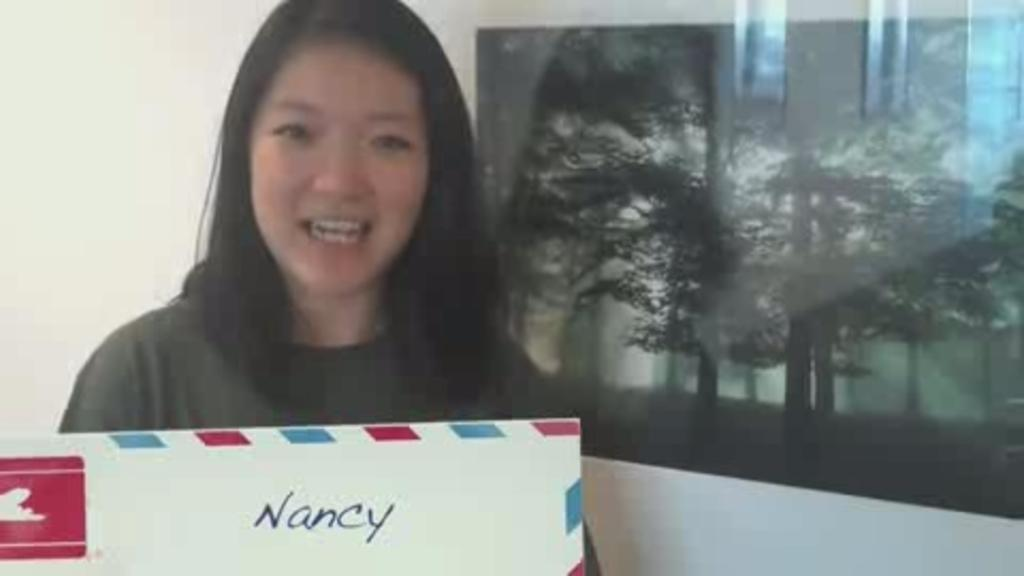Who is the main subject in the image? There is a woman in the image. What is the woman holding in the image? The woman is holding a board. Can you describe any other objects or features in the image? There is another board attached to the wall in the image. How many fangs can be seen on the woman in the image? There are no fangs visible on the woman in the image. What type of ladybug can be seen on the board in the image? There are no ladybugs present in the image. 